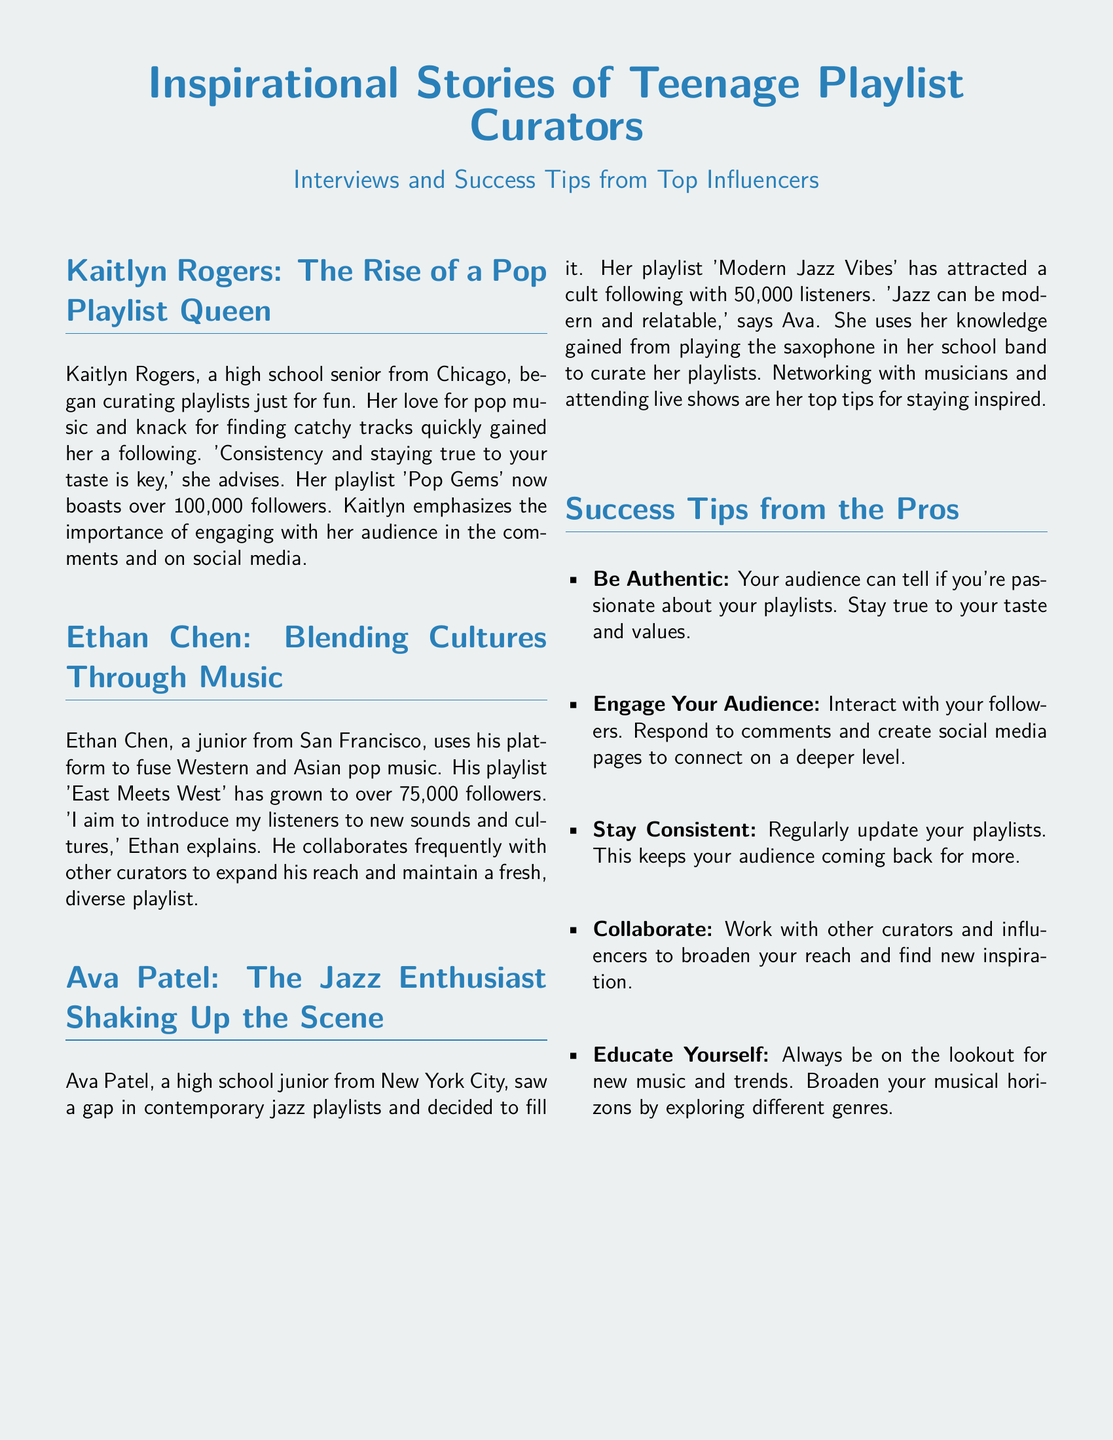What is Kaitlyn Rogers' Spotify playlist title? The document mentions Kaitlyn Rogers' playlist, which is titled 'Pop Gems.'
Answer: Pop Gems How many followers does Ethan Chen have? The document states that Ethan Chen's playlist 'East Meets West' has grown to over 75,000 followers.
Answer: 75,000 What instrument does Ava Patel play? The document specifies that Ava Patel plays the saxophone in her school band.
Answer: Saxophone What is a key success tip from the document? The document lists several tips, of which 'Be Authentic' is an example of what is recommended for success.
Answer: Be Authentic Which city is Kaitlyn Rogers from? The document indicates that Kaitlyn Rogers is a high school senior from Chicago.
Answer: Chicago How many followers does Ava Patel’s playlist have? The document states that Ava Patel's playlist 'Modern Jazz Vibes' has attracted a cult following with 50,000 listeners.
Answer: 50,000 What genre of music does Ethan Chen fuse in his playlists? The document explains that Ethan Chen fuses Western and Asian pop music in his playlists.
Answer: Western and Asian pop music What is one of Ava Patel's top tips for staying inspired? The document mentions that networking with musicians is one of Ava Patel's top tips.
Answer: Networking with musicians What is the primary focus of the Playbill document? The document focuses on inspirational stories from teenage playlist curators and their success tips.
Answer: Inspirational stories of teenage playlist curators 